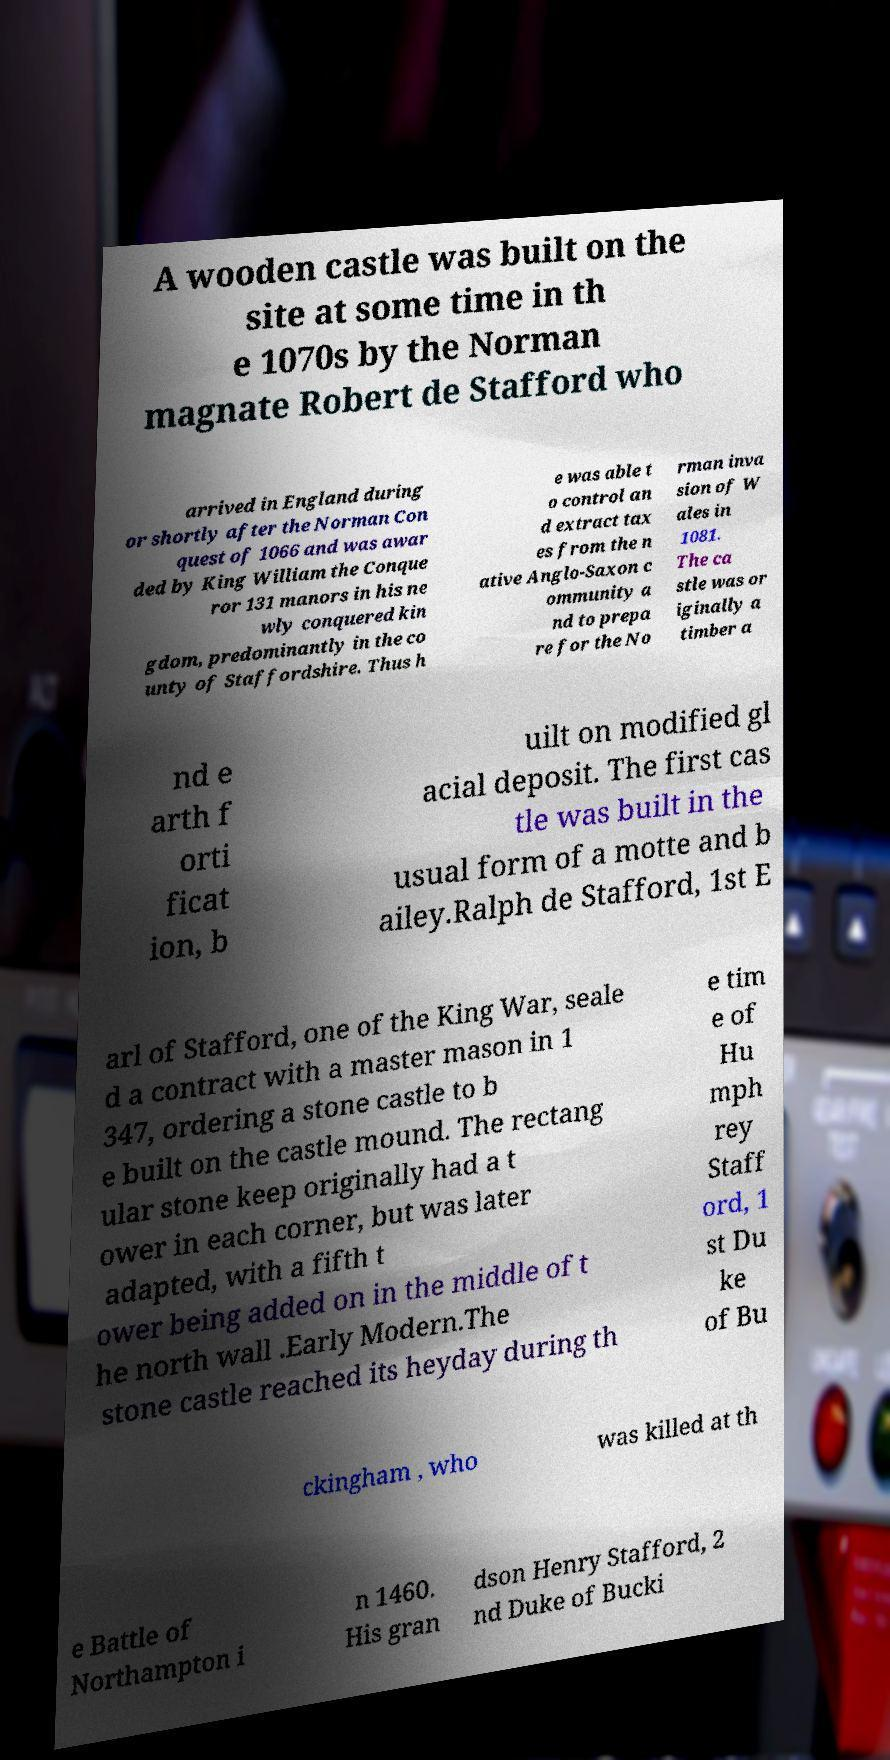Could you assist in decoding the text presented in this image and type it out clearly? A wooden castle was built on the site at some time in th e 1070s by the Norman magnate Robert de Stafford who arrived in England during or shortly after the Norman Con quest of 1066 and was awar ded by King William the Conque ror 131 manors in his ne wly conquered kin gdom, predominantly in the co unty of Staffordshire. Thus h e was able t o control an d extract tax es from the n ative Anglo-Saxon c ommunity a nd to prepa re for the No rman inva sion of W ales in 1081. The ca stle was or iginally a timber a nd e arth f orti ficat ion, b uilt on modified gl acial deposit. The first cas tle was built in the usual form of a motte and b ailey.Ralph de Stafford, 1st E arl of Stafford, one of the King War, seale d a contract with a master mason in 1 347, ordering a stone castle to b e built on the castle mound. The rectang ular stone keep originally had a t ower in each corner, but was later adapted, with a fifth t ower being added on in the middle of t he north wall .Early Modern.The stone castle reached its heyday during th e tim e of Hu mph rey Staff ord, 1 st Du ke of Bu ckingham , who was killed at th e Battle of Northampton i n 1460. His gran dson Henry Stafford, 2 nd Duke of Bucki 